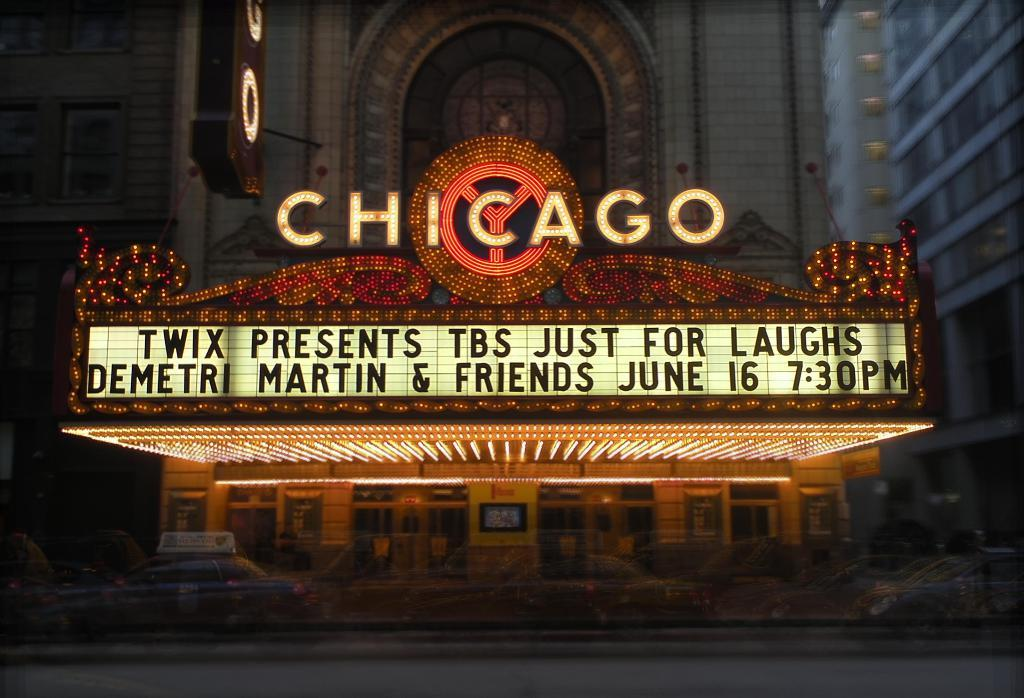What type of structures can be seen in the image? There are buildings in the image. Is there any text present in the image? Yes, there is text visible in the image. What is happening on the road in the image? Cars are moving on the road in the image. What brand of toothpaste is advertised on the buildings in the image? There is no toothpaste or advertisement present in the image; it only features buildings, text, and moving cars on the road. 